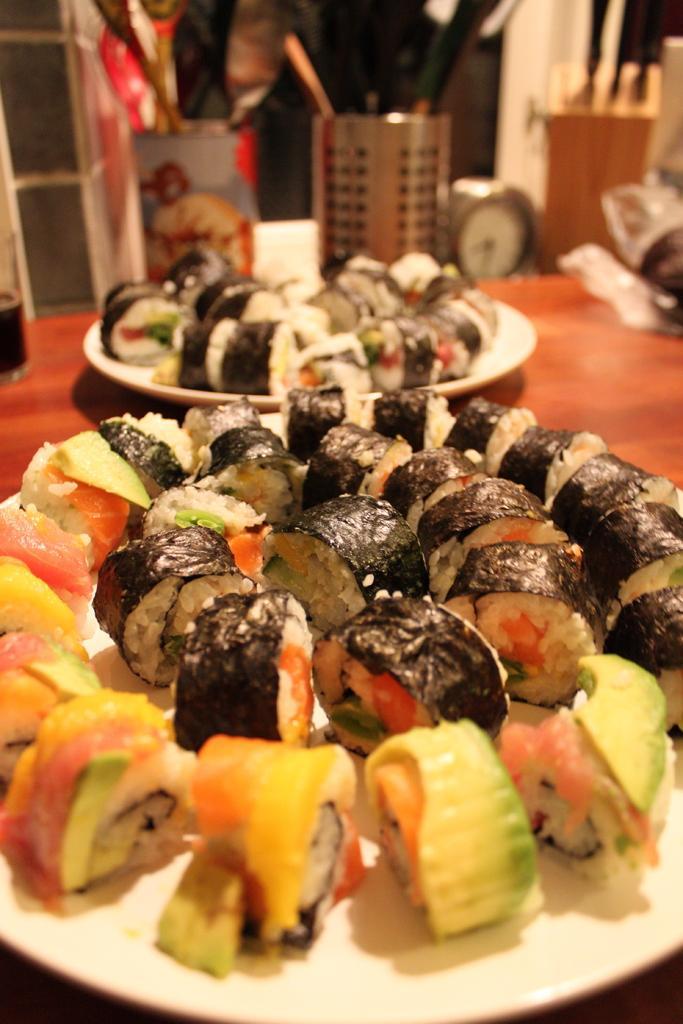How would you summarize this image in a sentence or two? In the picture we can see the table on it, we can see two plates with food items and behind it, we can see two stands with spoons and knives and beside it we can see the clock. 